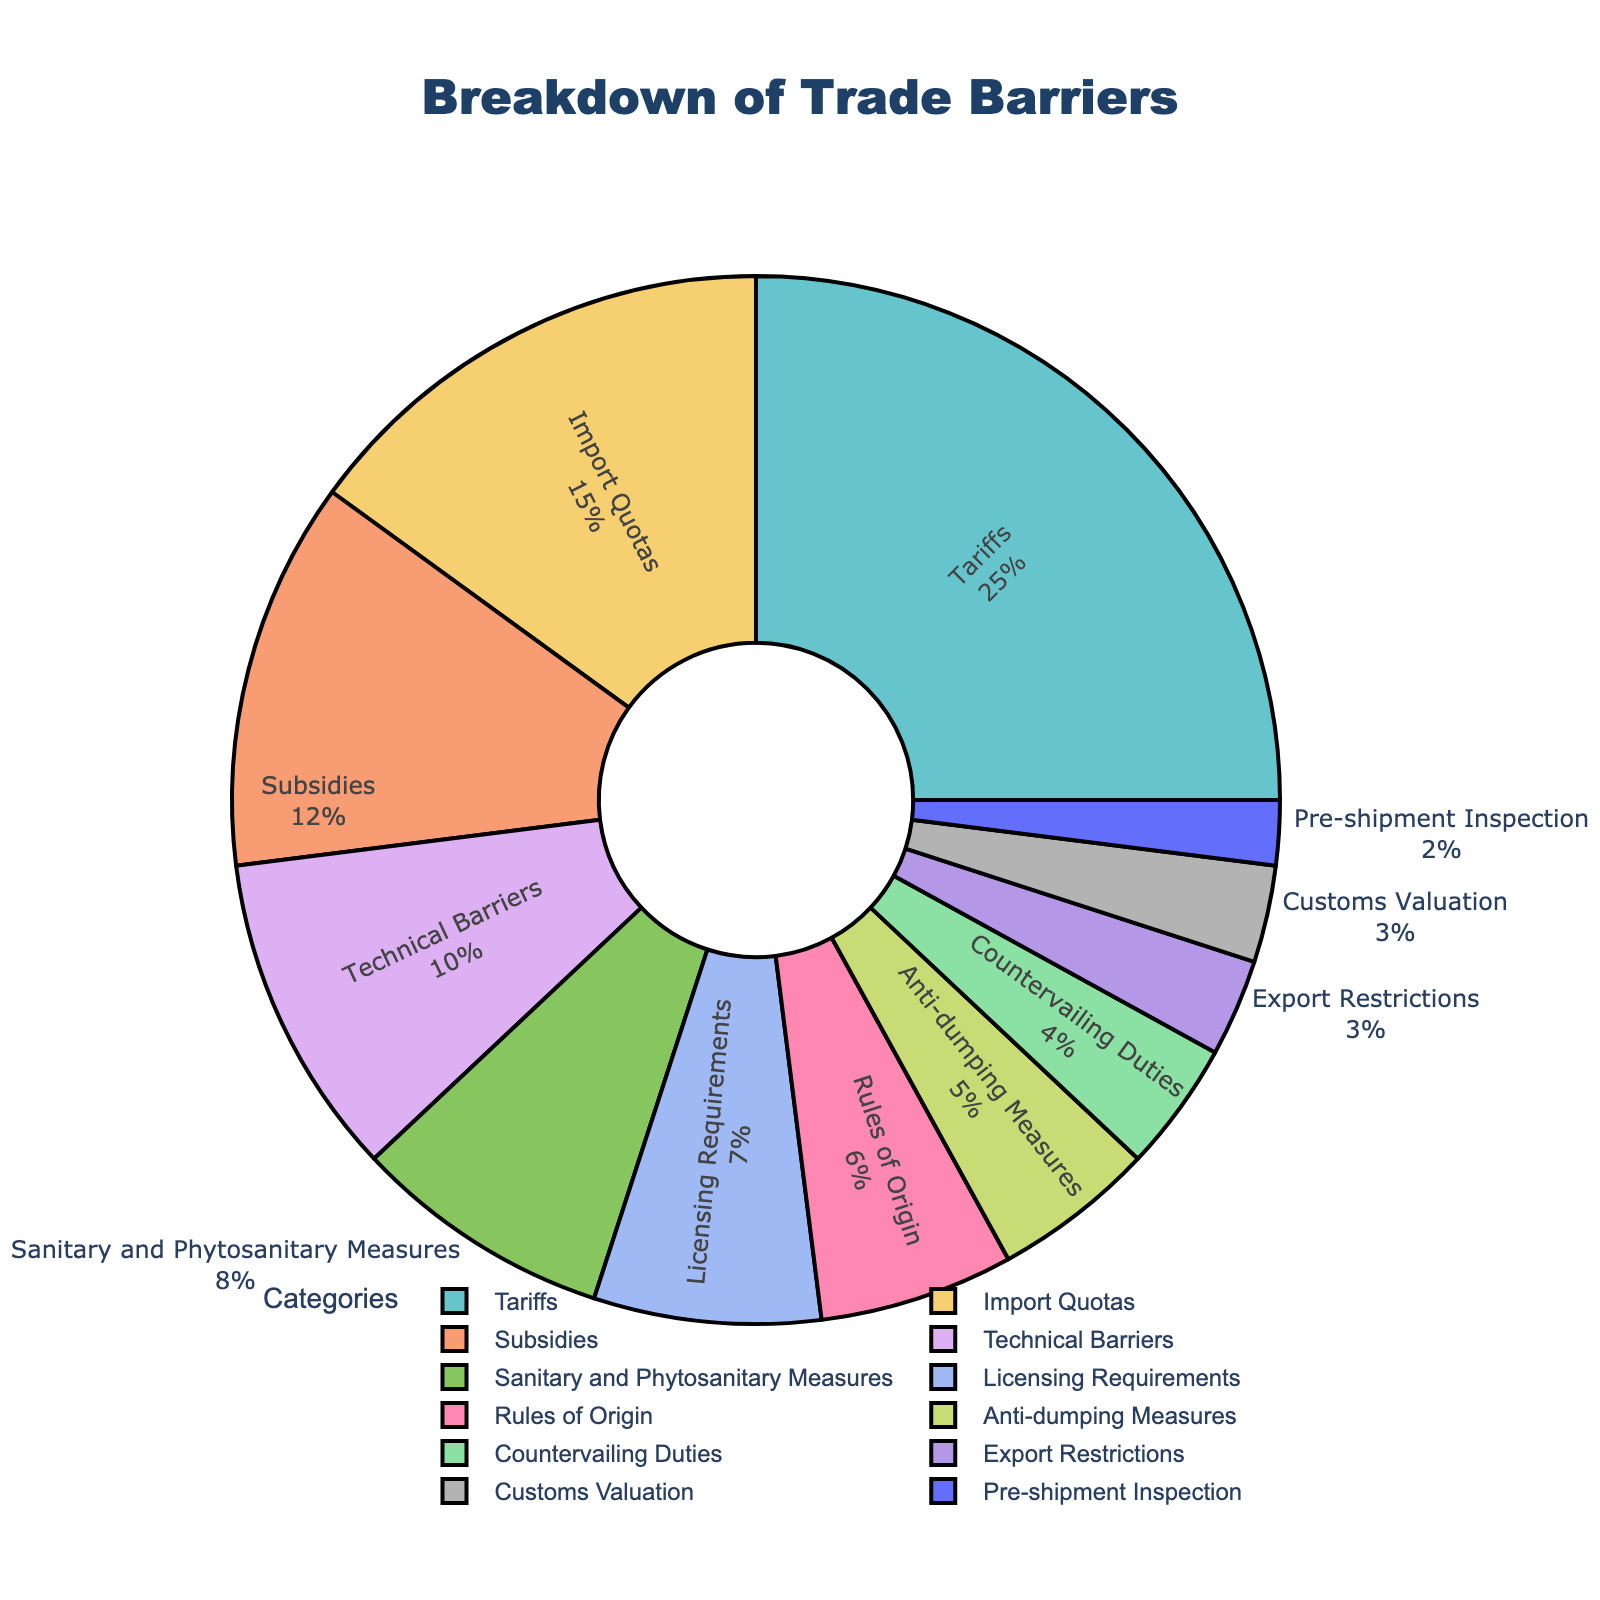What percentage of trade barriers are attributable to Tariffs and Import Quotas combined? Tariffs constitute 25% and Import Quotas make up 15%. Adding these together gives: 25% + 15% = 40%
Answer: 40% Which trade barrier category accounts for the smallest percentage? By looking at the chart, Pre-shipment Inspection represents the smallest percentage at 2%.
Answer: Pre-shipment Inspection How much greater is the percentage of Tariffs compared to Export Restrictions? The percentage for Tariffs is 25%, while for Export Restrictions it is 3%. Subtracting these gives: 25% - 3% = 22%
Answer: 22% What is the combined percentage of all non-tariff barriers? Adding all non-tariff barriers: 15 + 12 + 10 + 8 + 7 + 6 + 5 + 4 + 3 + 3 + 2 = 75%
Answer: 75% What is the difference in percentage between the largest and the smallest trade barrier categories? The largest category is Tariffs (25%) and the smallest is Pre-shipment Inspection (2%). The difference is: 25% - 2% = 23%
Answer: 23% How does the percentage for Technical Barriers compare with Subsidies? The percentage for Technical Barriers is 10% and for Subsidies is 12%. Since 10% < 12%, Technical Barriers are less than Subsidies.
Answer: Technical Barriers are less Which category has the highest percentage in the pie chart? By examining the chart, Tariffs have the highest percentage at 25%.
Answer: Tariffs What is the sum of the percentages for Licensing Requirements and Rules of Origin? Licensing Requirements are 7% and Rules of Origin are 6%. Adding them gives: 7% + 6% = 13%
Answer: 13% Which category, Anti-dumping Measures or Countervailing Duties, takes up a higher percentage? Anti-dumping Measures have 5% and Countervailing Duties have 4%. Therefore, Anti-dumping Measures have a higher percentage.
Answer: Anti-dumping Measures Identify the trade barrier category represented by the light blue color. By referring to the pie chart, the light blue color represents Technical Barriers.
Answer: Technical Barriers 